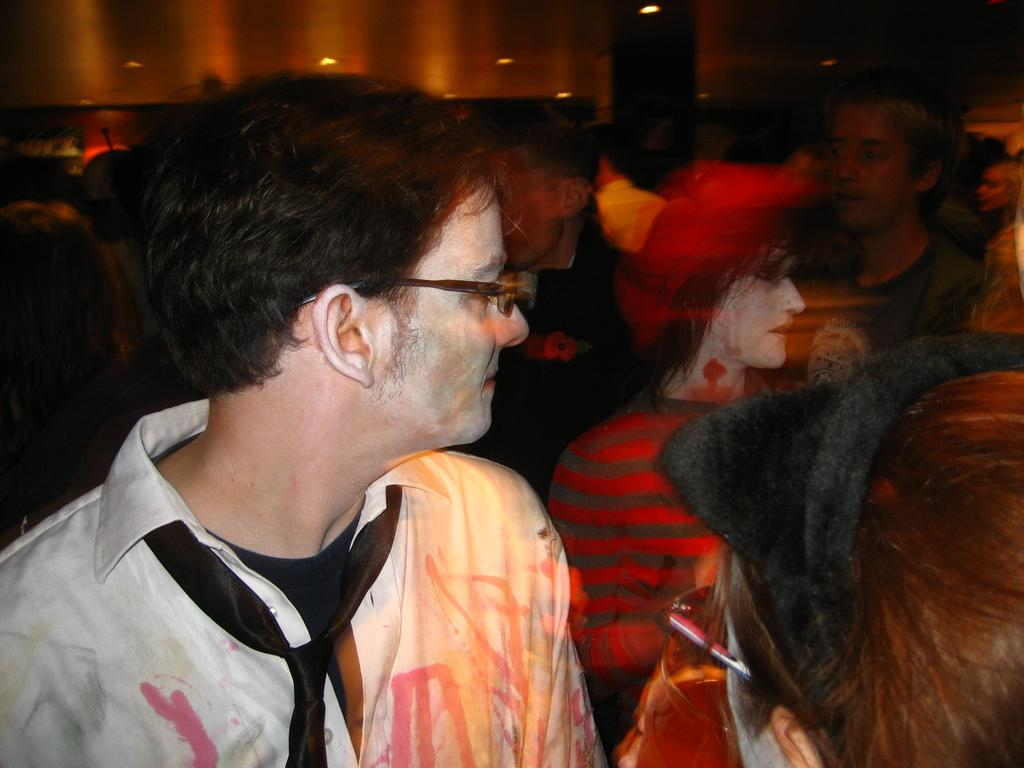What is a characteristic of one person in the image? There is a person with spectacles in the image. How many people are in the image? There is a group of people in the image. What can be seen illuminating the scene in the image? There are lights visible in the image. What is the appearance of the background in the image? The background of the image is blurred. What type of berry is being served in the hospital in the image? There is no berry or hospital present in the image; it features a group of people with lights and a blurred background. 